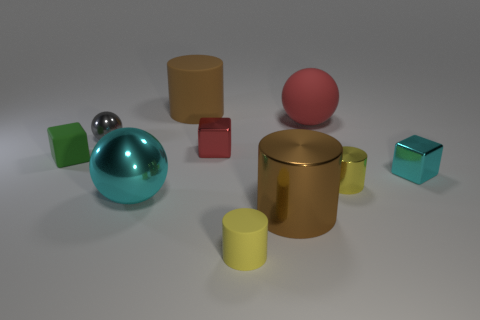Subtract all spheres. How many objects are left? 7 Add 6 big blue cylinders. How many big blue cylinders exist? 6 Subtract 1 red blocks. How many objects are left? 9 Subtract all yellow things. Subtract all green rubber things. How many objects are left? 7 Add 4 red objects. How many red objects are left? 6 